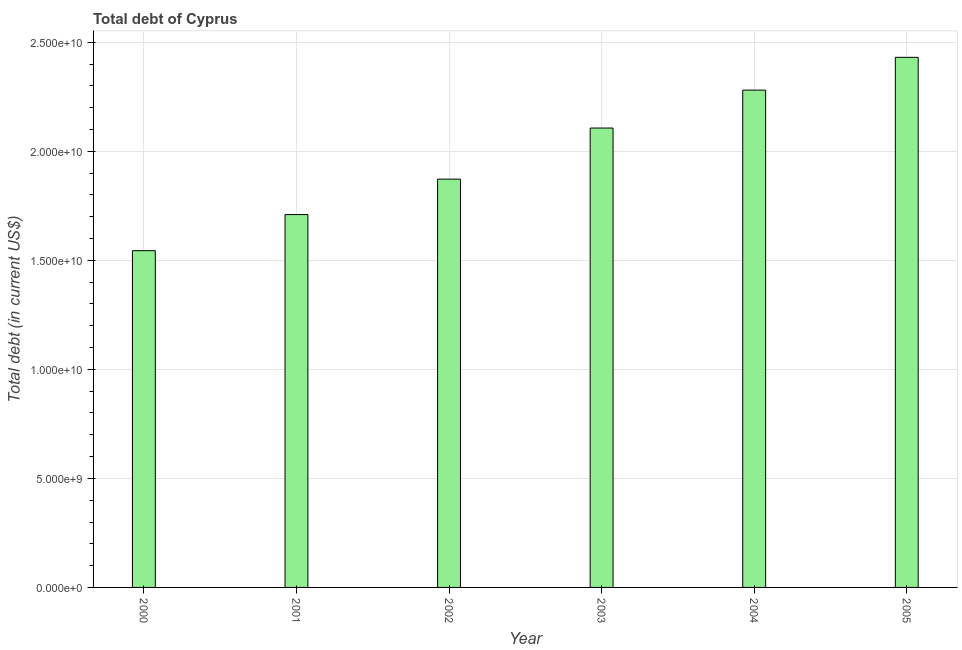Does the graph contain grids?
Keep it short and to the point. Yes. What is the title of the graph?
Keep it short and to the point. Total debt of Cyprus. What is the label or title of the X-axis?
Your response must be concise. Year. What is the label or title of the Y-axis?
Make the answer very short. Total debt (in current US$). What is the total debt in 2001?
Your answer should be very brief. 1.71e+1. Across all years, what is the maximum total debt?
Offer a terse response. 2.43e+1. Across all years, what is the minimum total debt?
Your answer should be compact. 1.54e+1. In which year was the total debt minimum?
Your response must be concise. 2000. What is the sum of the total debt?
Your answer should be very brief. 1.19e+11. What is the difference between the total debt in 2001 and 2002?
Your answer should be very brief. -1.62e+09. What is the average total debt per year?
Provide a succinct answer. 1.99e+1. What is the median total debt?
Keep it short and to the point. 1.99e+1. What is the ratio of the total debt in 2003 to that in 2005?
Offer a very short reply. 0.87. Is the total debt in 2000 less than that in 2005?
Give a very brief answer. Yes. Is the difference between the total debt in 2001 and 2003 greater than the difference between any two years?
Your answer should be compact. No. What is the difference between the highest and the second highest total debt?
Your answer should be very brief. 1.50e+09. What is the difference between the highest and the lowest total debt?
Keep it short and to the point. 8.87e+09. What is the Total debt (in current US$) in 2000?
Make the answer very short. 1.54e+1. What is the Total debt (in current US$) in 2001?
Provide a succinct answer. 1.71e+1. What is the Total debt (in current US$) of 2002?
Ensure brevity in your answer.  1.87e+1. What is the Total debt (in current US$) in 2003?
Provide a succinct answer. 2.11e+1. What is the Total debt (in current US$) of 2004?
Offer a very short reply. 2.28e+1. What is the Total debt (in current US$) of 2005?
Offer a terse response. 2.43e+1. What is the difference between the Total debt (in current US$) in 2000 and 2001?
Offer a terse response. -1.66e+09. What is the difference between the Total debt (in current US$) in 2000 and 2002?
Your response must be concise. -3.28e+09. What is the difference between the Total debt (in current US$) in 2000 and 2003?
Provide a succinct answer. -5.62e+09. What is the difference between the Total debt (in current US$) in 2000 and 2004?
Keep it short and to the point. -7.36e+09. What is the difference between the Total debt (in current US$) in 2000 and 2005?
Offer a terse response. -8.87e+09. What is the difference between the Total debt (in current US$) in 2001 and 2002?
Provide a short and direct response. -1.62e+09. What is the difference between the Total debt (in current US$) in 2001 and 2003?
Your answer should be compact. -3.97e+09. What is the difference between the Total debt (in current US$) in 2001 and 2004?
Offer a terse response. -5.71e+09. What is the difference between the Total debt (in current US$) in 2001 and 2005?
Your answer should be very brief. -7.21e+09. What is the difference between the Total debt (in current US$) in 2002 and 2003?
Ensure brevity in your answer.  -2.34e+09. What is the difference between the Total debt (in current US$) in 2002 and 2004?
Give a very brief answer. -4.08e+09. What is the difference between the Total debt (in current US$) in 2002 and 2005?
Your answer should be compact. -5.59e+09. What is the difference between the Total debt (in current US$) in 2003 and 2004?
Offer a very short reply. -1.74e+09. What is the difference between the Total debt (in current US$) in 2003 and 2005?
Your response must be concise. -3.24e+09. What is the difference between the Total debt (in current US$) in 2004 and 2005?
Ensure brevity in your answer.  -1.50e+09. What is the ratio of the Total debt (in current US$) in 2000 to that in 2001?
Offer a very short reply. 0.9. What is the ratio of the Total debt (in current US$) in 2000 to that in 2002?
Keep it short and to the point. 0.82. What is the ratio of the Total debt (in current US$) in 2000 to that in 2003?
Your answer should be very brief. 0.73. What is the ratio of the Total debt (in current US$) in 2000 to that in 2004?
Give a very brief answer. 0.68. What is the ratio of the Total debt (in current US$) in 2000 to that in 2005?
Provide a succinct answer. 0.64. What is the ratio of the Total debt (in current US$) in 2001 to that in 2003?
Offer a very short reply. 0.81. What is the ratio of the Total debt (in current US$) in 2001 to that in 2004?
Give a very brief answer. 0.75. What is the ratio of the Total debt (in current US$) in 2001 to that in 2005?
Provide a short and direct response. 0.7. What is the ratio of the Total debt (in current US$) in 2002 to that in 2003?
Offer a very short reply. 0.89. What is the ratio of the Total debt (in current US$) in 2002 to that in 2004?
Keep it short and to the point. 0.82. What is the ratio of the Total debt (in current US$) in 2002 to that in 2005?
Your response must be concise. 0.77. What is the ratio of the Total debt (in current US$) in 2003 to that in 2004?
Offer a terse response. 0.92. What is the ratio of the Total debt (in current US$) in 2003 to that in 2005?
Ensure brevity in your answer.  0.87. What is the ratio of the Total debt (in current US$) in 2004 to that in 2005?
Ensure brevity in your answer.  0.94. 